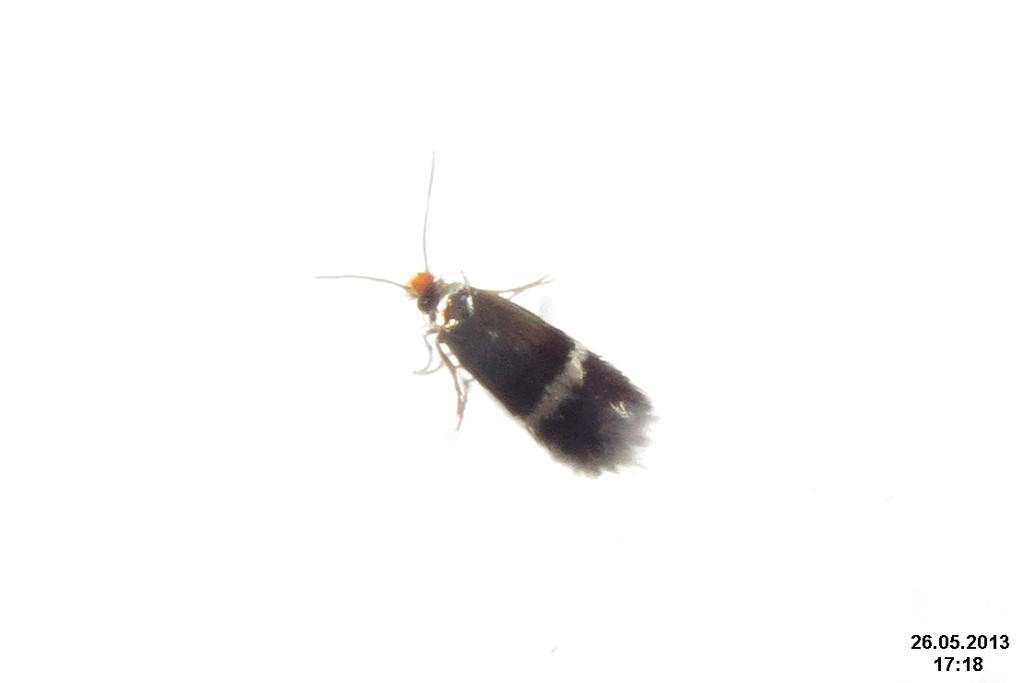What type of creature can be seen in the picture? There is an insect in the picture. What color is the background of the image? The background of the image is white. Is there any text or information visible in the image? Yes, there is a date and time written in the bottom right corner of the image. What type of furniture is visible in the image? There is no furniture present in the image; it features an insect against a white background. What color is the silverware in the image? There is no silverware present in the image. 